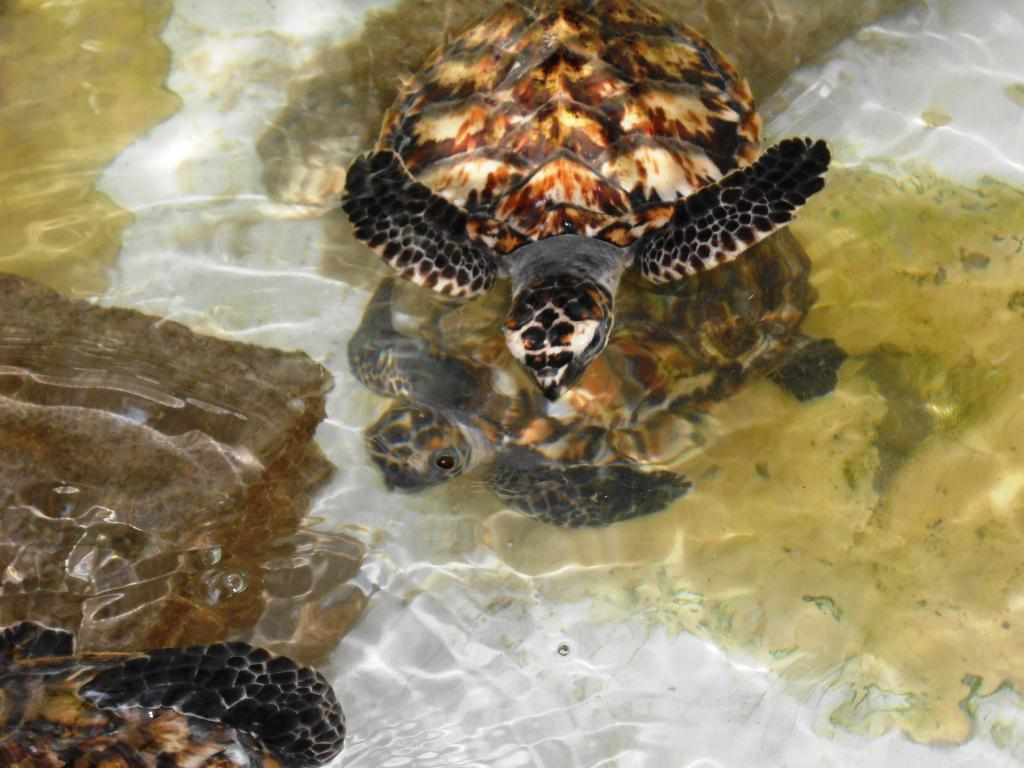What type of animals are in the image? There are turtles in the image. What is the primary element in which the turtles are situated? There is water visible in the image. What part of the natural environment is visible in the image? The ground is visible in the image. What type of tooth can be seen in the image? There is no tooth present in the image; it features turtles in water. 